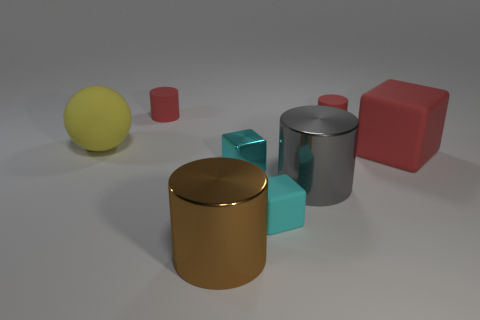Is there any other thing that is the same color as the shiny cube?
Make the answer very short. Yes. Is there a metallic cylinder that has the same size as the yellow rubber thing?
Make the answer very short. Yes. Are there fewer cyan metal objects that are behind the large red matte thing than big brown shiny cylinders?
Your answer should be compact. Yes. There is a red object that is in front of the large rubber thing behind the red matte object in front of the yellow rubber thing; what is it made of?
Provide a succinct answer. Rubber. Are there more rubber objects that are in front of the large yellow matte sphere than cyan shiny blocks that are right of the large red object?
Your response must be concise. Yes. What number of rubber things are gray cylinders or red things?
Give a very brief answer. 3. There is a shiny object that is the same color as the tiny matte cube; what is its shape?
Give a very brief answer. Cube. There is a big brown thing in front of the gray metal object; what is it made of?
Your answer should be compact. Metal. How many things are either tiny cyan things or small rubber things that are right of the big brown metal object?
Give a very brief answer. 3. What is the shape of the brown metal thing that is the same size as the gray metal cylinder?
Give a very brief answer. Cylinder. 